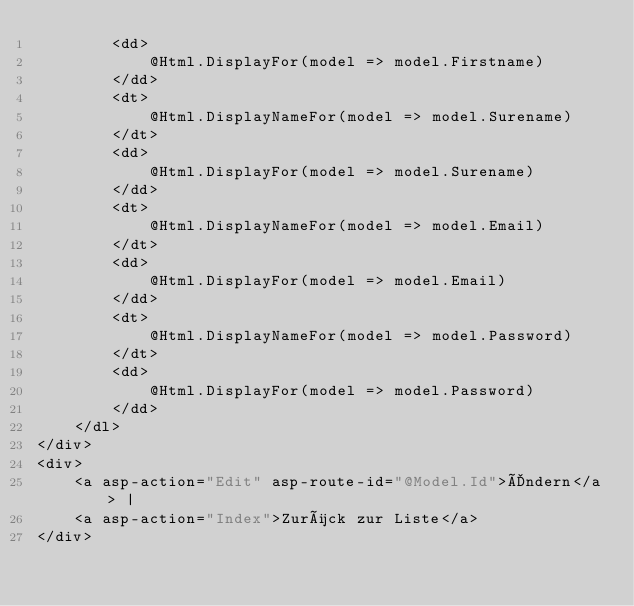Convert code to text. <code><loc_0><loc_0><loc_500><loc_500><_C#_>        <dd>
            @Html.DisplayFor(model => model.Firstname)
        </dd>
        <dt>
            @Html.DisplayNameFor(model => model.Surename)
        </dt>
        <dd>
            @Html.DisplayFor(model => model.Surename)
        </dd>
        <dt>
            @Html.DisplayNameFor(model => model.Email)
        </dt>
        <dd>
            @Html.DisplayFor(model => model.Email)
        </dd>
        <dt>
            @Html.DisplayNameFor(model => model.Password)
        </dt>
        <dd>
            @Html.DisplayFor(model => model.Password)
        </dd>
    </dl>
</div>
<div>
    <a asp-action="Edit" asp-route-id="@Model.Id">Ändern</a> |
    <a asp-action="Index">Zurück zur Liste</a>
</div>
</code> 